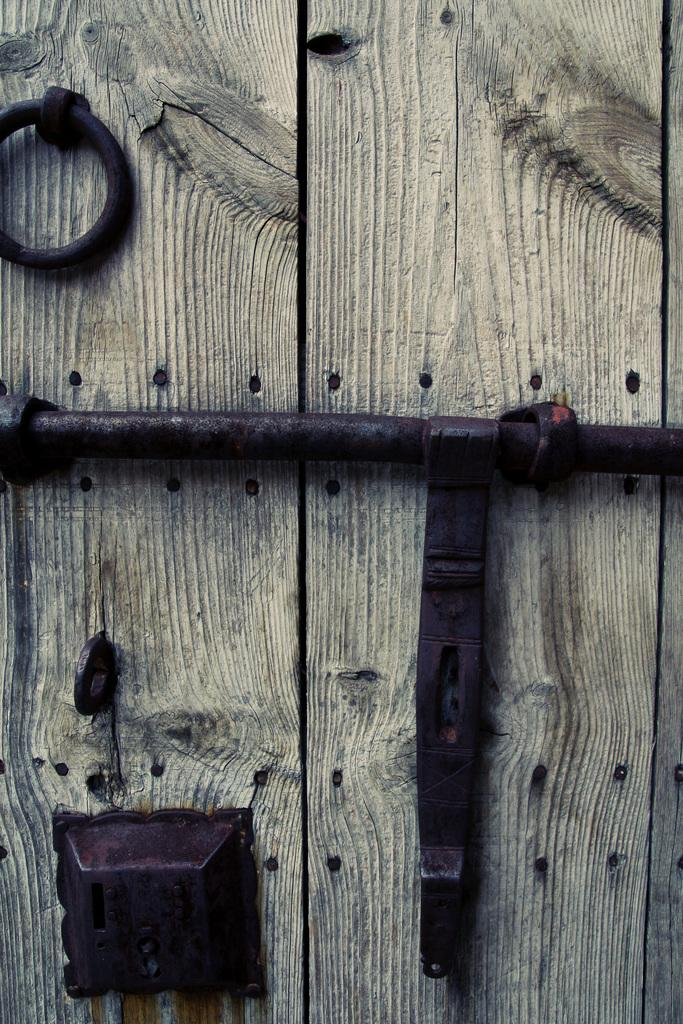What type of door is shown in the image? There is a wooden door in the image. What security feature is present at the bottom of the wooden door? There is a door lock at the bottom of the wooden door. What additional security feature can be seen in the middle of the image? There is a door hasp in the middle of the image. What color is the door hasp? The door hasp is black in color. What type of collar can be seen on the door in the image? There is no collar present on the door in the image. How does the crowd react to the door in the image? There is no crowd present in the image, so it is not possible to determine how they would react to the door. 